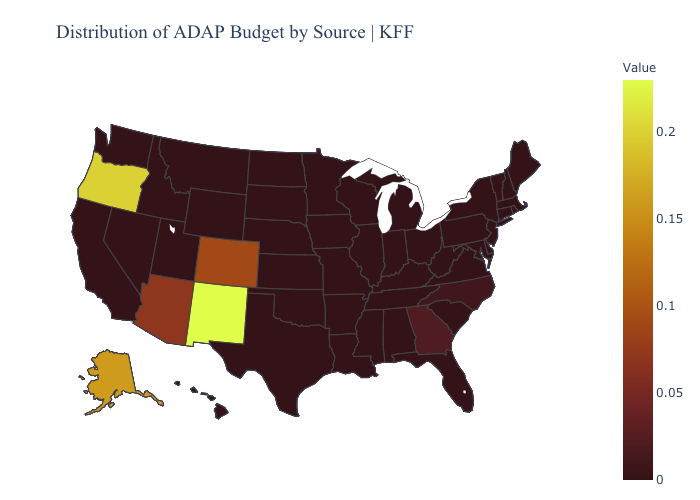Among the states that border Utah , which have the highest value?
Write a very short answer. New Mexico. Among the states that border Colorado , which have the highest value?
Be succinct. New Mexico. Which states have the lowest value in the West?
Give a very brief answer. California, Hawaii, Idaho, Montana, Nevada, Utah, Washington, Wyoming. Does Georgia have the highest value in the South?
Write a very short answer. Yes. 